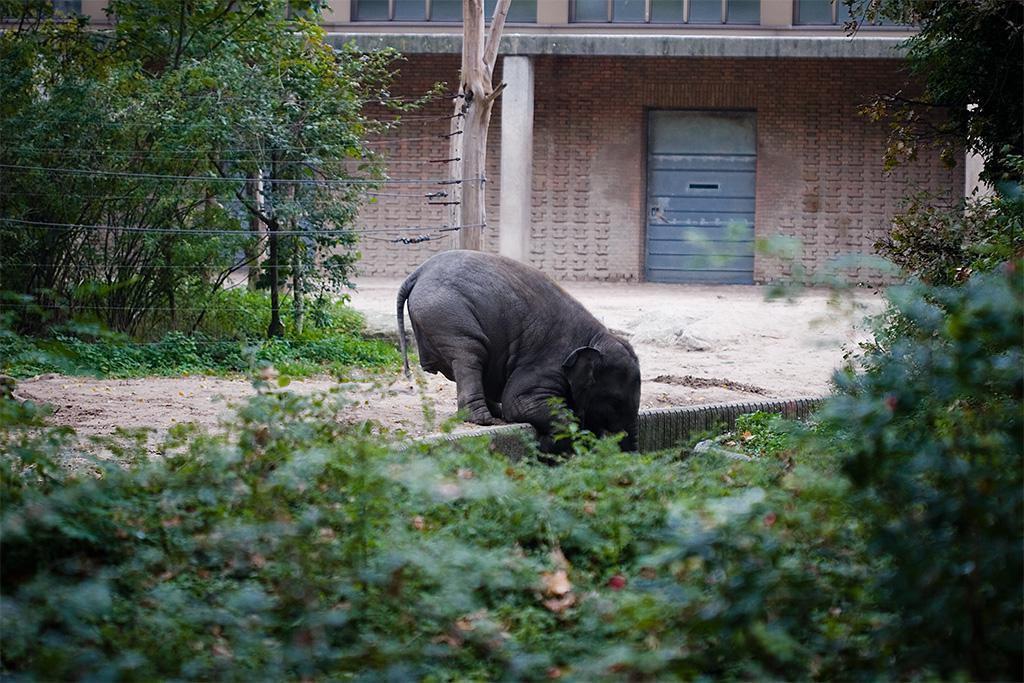What type of animal is in the image? The type of animal cannot be determined from the provided facts. What other elements are present in the image besides the animal? There are plants and a house in the image. Can you describe the plants in the image? The provided facts do not give enough information to describe the plants in the image. What is the condition of the house in the image? The condition of the house cannot be determined from the provided facts. How does the animal support itself while twisting its body in the image? There is no information about the animal's body or actions in the image, so it cannot be determined how it supports itself or twists its body. 